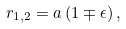Convert formula to latex. <formula><loc_0><loc_0><loc_500><loc_500>r _ { 1 , 2 } = a \left ( 1 \mp \epsilon \right ) ,</formula> 